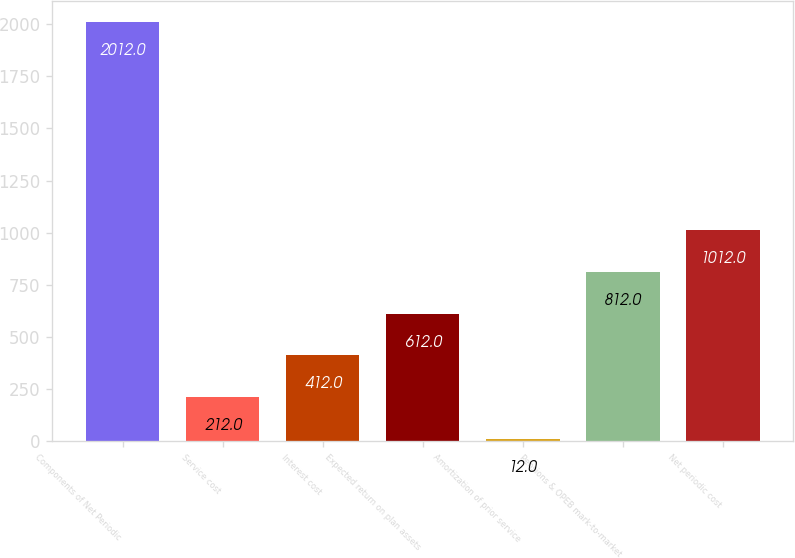Convert chart. <chart><loc_0><loc_0><loc_500><loc_500><bar_chart><fcel>Components of Net Periodic<fcel>Service cost<fcel>Interest cost<fcel>Expected return on plan assets<fcel>Amortization of prior service<fcel>Pensions & OPEB mark-to-market<fcel>Net periodic cost<nl><fcel>2012<fcel>212<fcel>412<fcel>612<fcel>12<fcel>812<fcel>1012<nl></chart> 